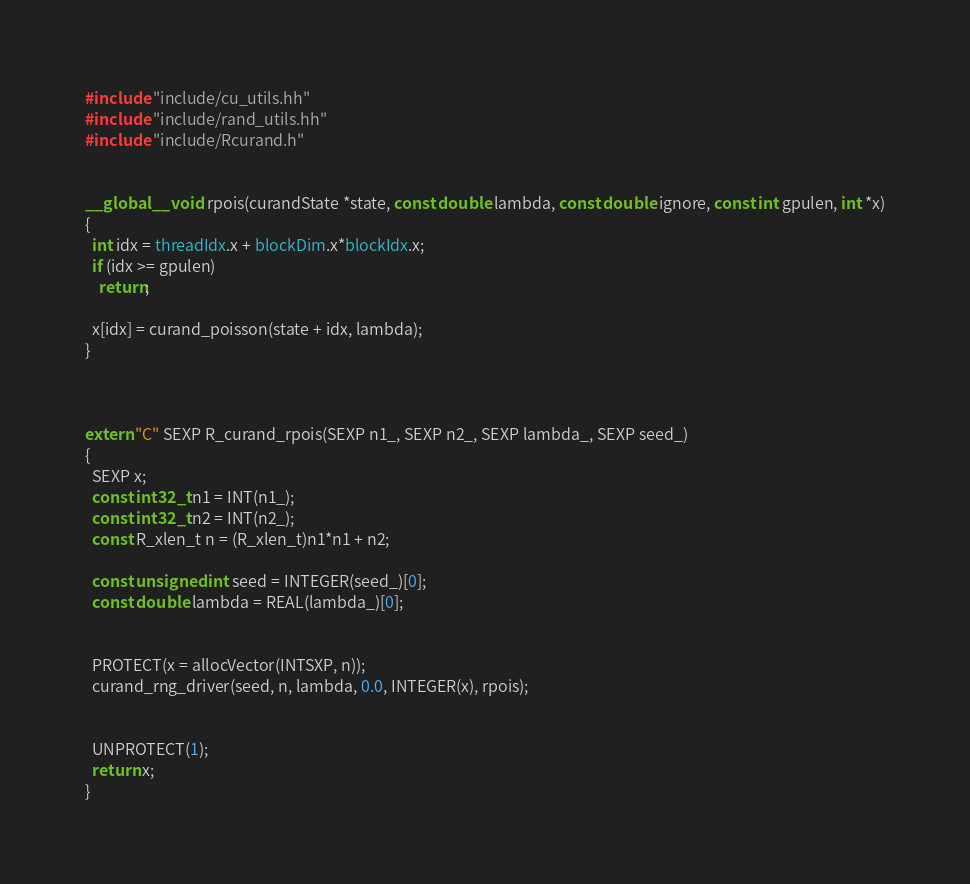Convert code to text. <code><loc_0><loc_0><loc_500><loc_500><_Cuda_>#include "include/cu_utils.hh"
#include "include/rand_utils.hh"
#include "include/Rcurand.h"


__global__ void rpois(curandState *state, const double lambda, const double ignore, const int gpulen, int *x)
{
  int idx = threadIdx.x + blockDim.x*blockIdx.x;
  if (idx >= gpulen)
    return;
  
  x[idx] = curand_poisson(state + idx, lambda);
}



extern "C" SEXP R_curand_rpois(SEXP n1_, SEXP n2_, SEXP lambda_, SEXP seed_)
{
  SEXP x;
  const int32_t n1 = INT(n1_);
  const int32_t n2 = INT(n2_);
  const R_xlen_t n = (R_xlen_t)n1*n1 + n2;
  
  const unsigned int seed = INTEGER(seed_)[0];
  const double lambda = REAL(lambda_)[0];
  
  
  PROTECT(x = allocVector(INTSXP, n));
  curand_rng_driver(seed, n, lambda, 0.0, INTEGER(x), rpois);
  
  
  UNPROTECT(1);
  return x;
}
</code> 